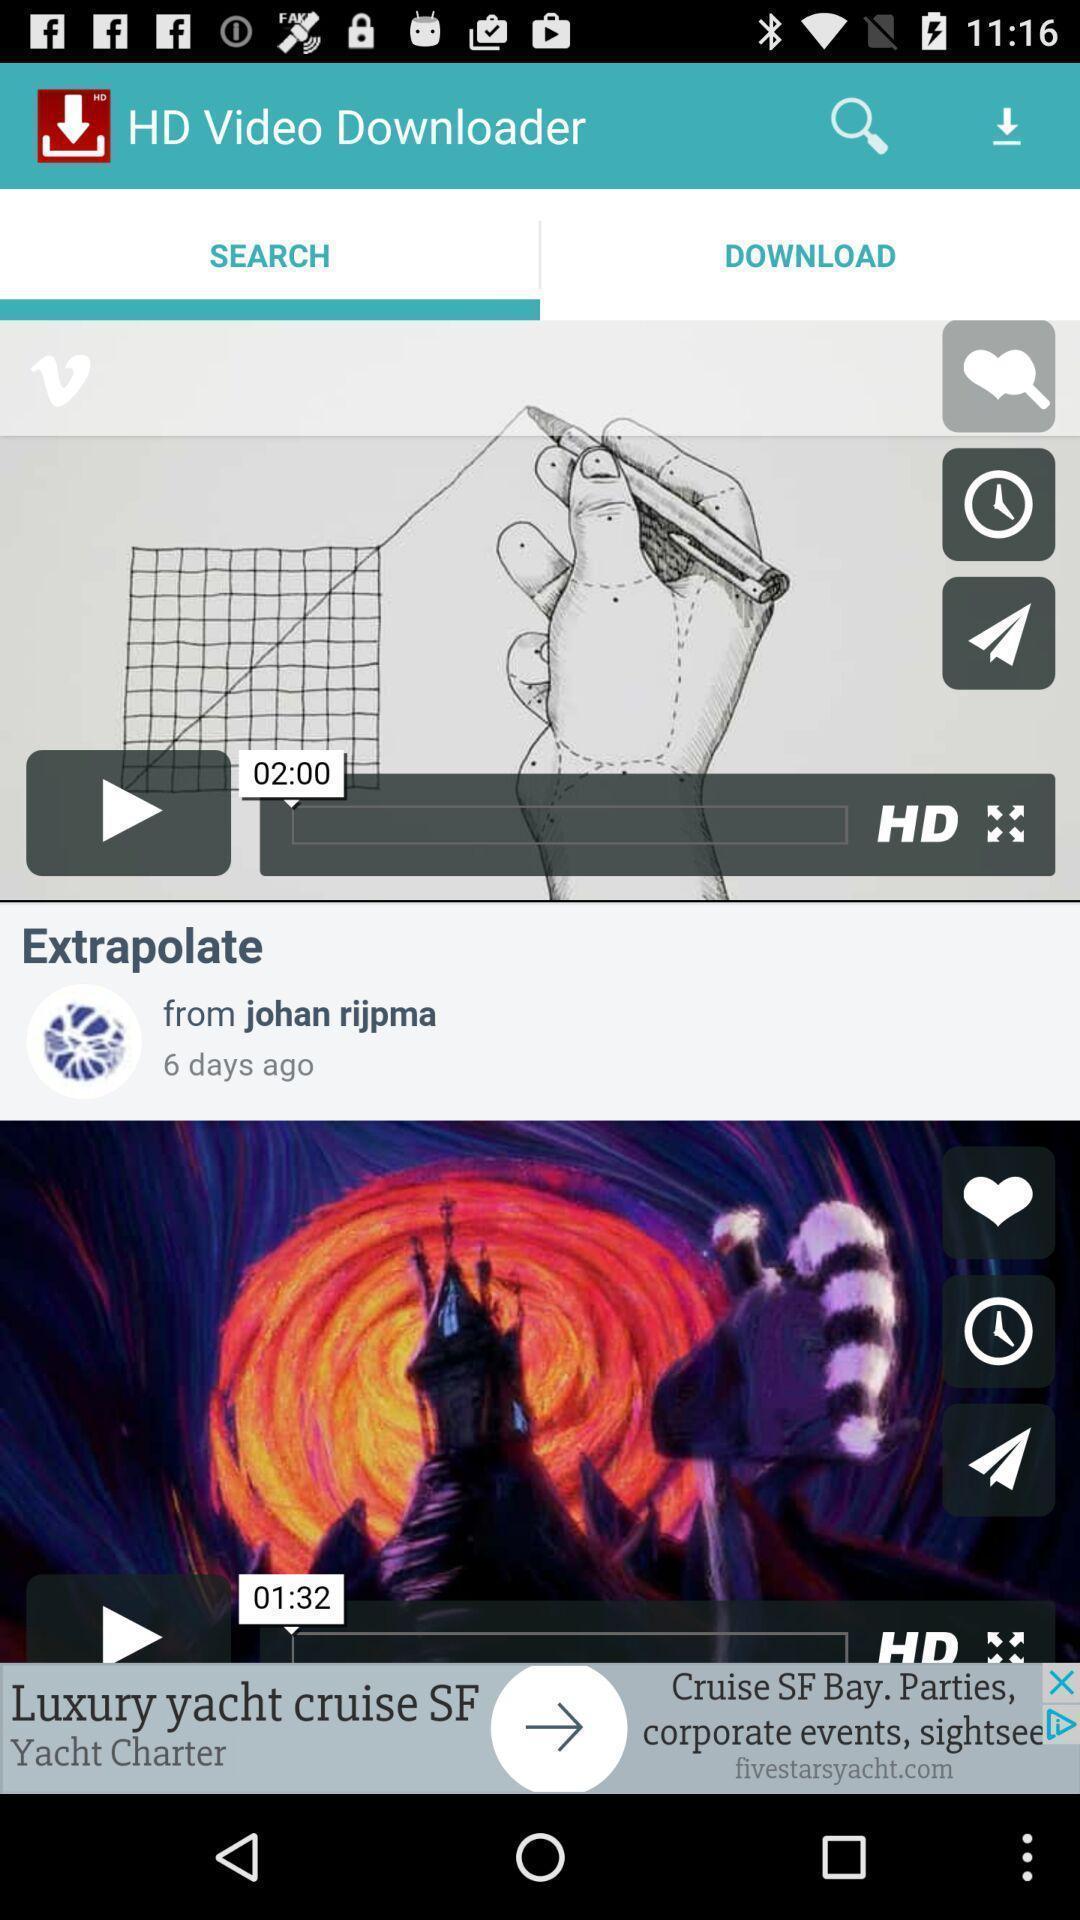Tell me what you see in this picture. Search bar to search the hd video downloader. 